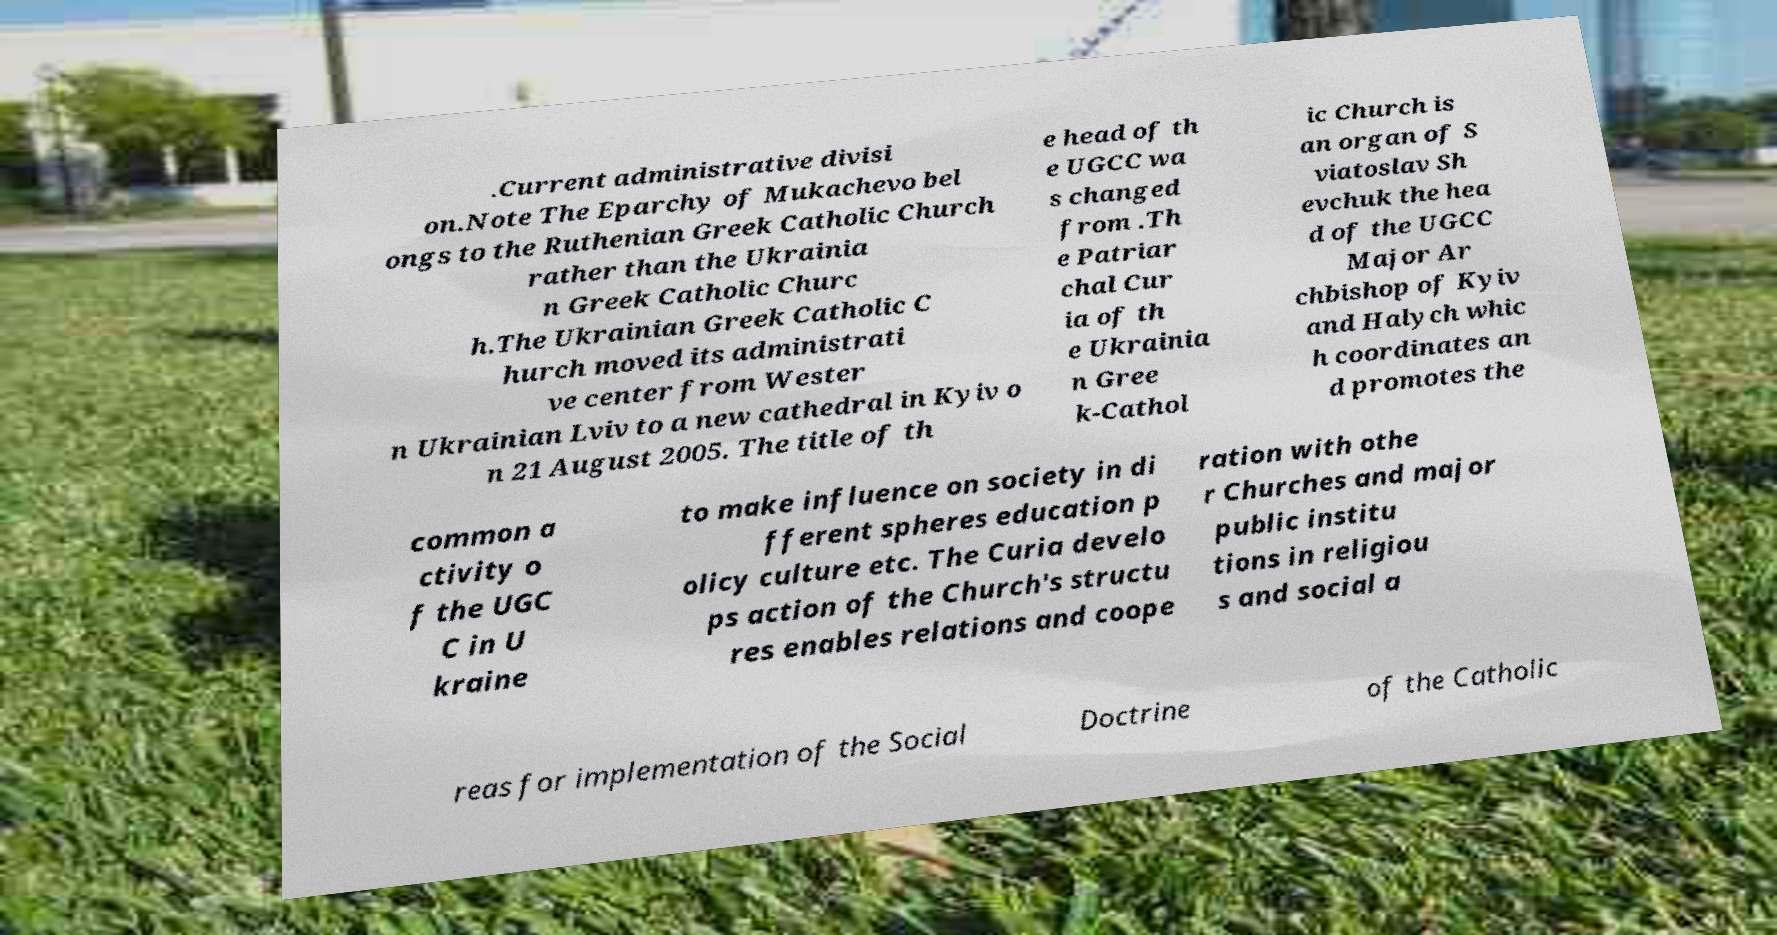Please read and relay the text visible in this image. What does it say? .Current administrative divisi on.Note The Eparchy of Mukachevo bel ongs to the Ruthenian Greek Catholic Church rather than the Ukrainia n Greek Catholic Churc h.The Ukrainian Greek Catholic C hurch moved its administrati ve center from Wester n Ukrainian Lviv to a new cathedral in Kyiv o n 21 August 2005. The title of th e head of th e UGCC wa s changed from .Th e Patriar chal Cur ia of th e Ukrainia n Gree k-Cathol ic Church is an organ of S viatoslav Sh evchuk the hea d of the UGCC Major Ar chbishop of Kyiv and Halych whic h coordinates an d promotes the common a ctivity o f the UGC C in U kraine to make influence on society in di fferent spheres education p olicy culture etc. The Curia develo ps action of the Church's structu res enables relations and coope ration with othe r Churches and major public institu tions in religiou s and social a reas for implementation of the Social Doctrine of the Catholic 